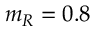<formula> <loc_0><loc_0><loc_500><loc_500>m _ { R } = 0 . 8</formula> 